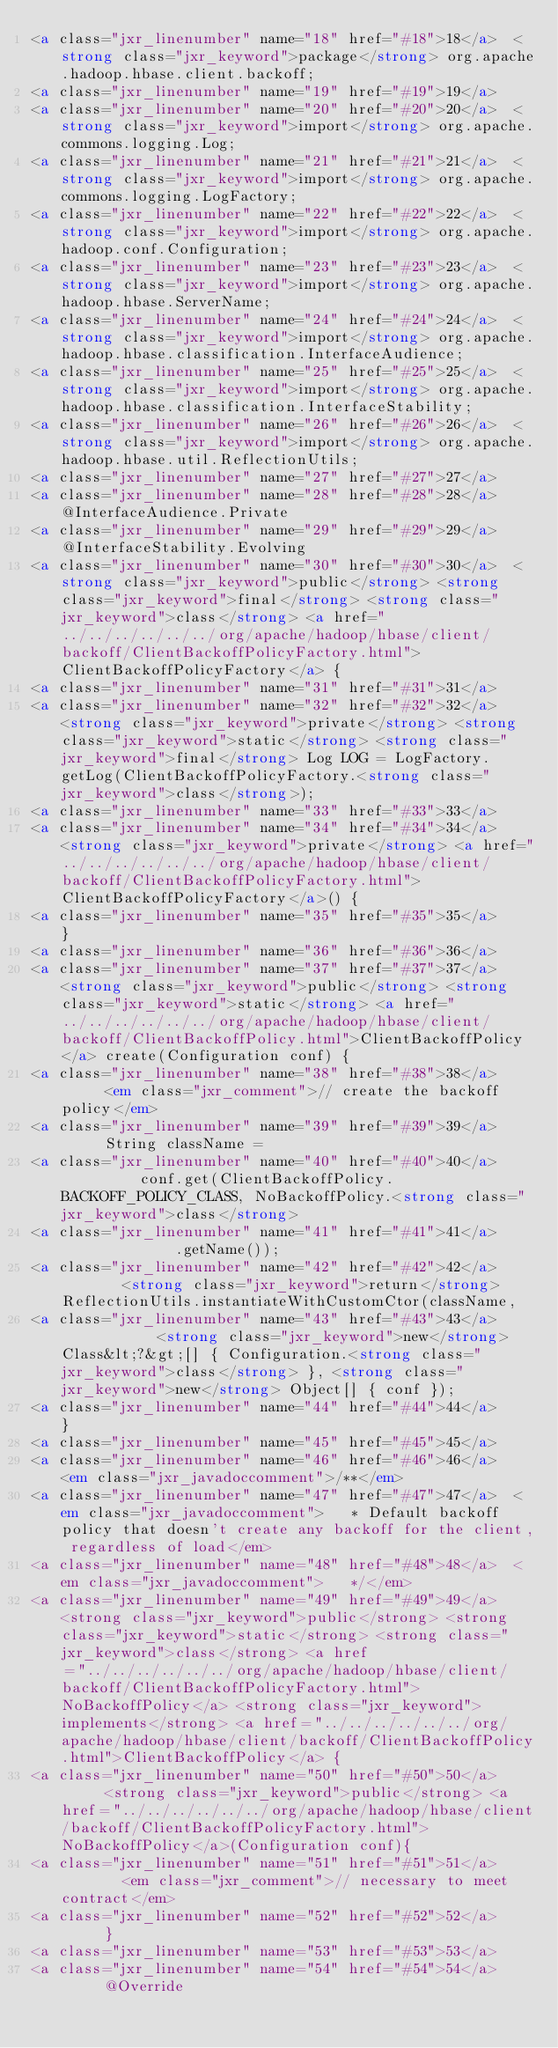Convert code to text. <code><loc_0><loc_0><loc_500><loc_500><_HTML_><a class="jxr_linenumber" name="18" href="#18">18</a>  <strong class="jxr_keyword">package</strong> org.apache.hadoop.hbase.client.backoff;
<a class="jxr_linenumber" name="19" href="#19">19</a>  
<a class="jxr_linenumber" name="20" href="#20">20</a>  <strong class="jxr_keyword">import</strong> org.apache.commons.logging.Log;
<a class="jxr_linenumber" name="21" href="#21">21</a>  <strong class="jxr_keyword">import</strong> org.apache.commons.logging.LogFactory;
<a class="jxr_linenumber" name="22" href="#22">22</a>  <strong class="jxr_keyword">import</strong> org.apache.hadoop.conf.Configuration;
<a class="jxr_linenumber" name="23" href="#23">23</a>  <strong class="jxr_keyword">import</strong> org.apache.hadoop.hbase.ServerName;
<a class="jxr_linenumber" name="24" href="#24">24</a>  <strong class="jxr_keyword">import</strong> org.apache.hadoop.hbase.classification.InterfaceAudience;
<a class="jxr_linenumber" name="25" href="#25">25</a>  <strong class="jxr_keyword">import</strong> org.apache.hadoop.hbase.classification.InterfaceStability;
<a class="jxr_linenumber" name="26" href="#26">26</a>  <strong class="jxr_keyword">import</strong> org.apache.hadoop.hbase.util.ReflectionUtils;
<a class="jxr_linenumber" name="27" href="#27">27</a>  
<a class="jxr_linenumber" name="28" href="#28">28</a>  @InterfaceAudience.Private
<a class="jxr_linenumber" name="29" href="#29">29</a>  @InterfaceStability.Evolving
<a class="jxr_linenumber" name="30" href="#30">30</a>  <strong class="jxr_keyword">public</strong> <strong class="jxr_keyword">final</strong> <strong class="jxr_keyword">class</strong> <a href="../../../../../../org/apache/hadoop/hbase/client/backoff/ClientBackoffPolicyFactory.html">ClientBackoffPolicyFactory</a> {
<a class="jxr_linenumber" name="31" href="#31">31</a>  
<a class="jxr_linenumber" name="32" href="#32">32</a>    <strong class="jxr_keyword">private</strong> <strong class="jxr_keyword">static</strong> <strong class="jxr_keyword">final</strong> Log LOG = LogFactory.getLog(ClientBackoffPolicyFactory.<strong class="jxr_keyword">class</strong>);
<a class="jxr_linenumber" name="33" href="#33">33</a>  
<a class="jxr_linenumber" name="34" href="#34">34</a>    <strong class="jxr_keyword">private</strong> <a href="../../../../../../org/apache/hadoop/hbase/client/backoff/ClientBackoffPolicyFactory.html">ClientBackoffPolicyFactory</a>() {
<a class="jxr_linenumber" name="35" href="#35">35</a>    }
<a class="jxr_linenumber" name="36" href="#36">36</a>  
<a class="jxr_linenumber" name="37" href="#37">37</a>    <strong class="jxr_keyword">public</strong> <strong class="jxr_keyword">static</strong> <a href="../../../../../../org/apache/hadoop/hbase/client/backoff/ClientBackoffPolicy.html">ClientBackoffPolicy</a> create(Configuration conf) {
<a class="jxr_linenumber" name="38" href="#38">38</a>      <em class="jxr_comment">// create the backoff policy</em>
<a class="jxr_linenumber" name="39" href="#39">39</a>      String className =
<a class="jxr_linenumber" name="40" href="#40">40</a>          conf.get(ClientBackoffPolicy.BACKOFF_POLICY_CLASS, NoBackoffPolicy.<strong class="jxr_keyword">class</strong>
<a class="jxr_linenumber" name="41" href="#41">41</a>              .getName());
<a class="jxr_linenumber" name="42" href="#42">42</a>        <strong class="jxr_keyword">return</strong> ReflectionUtils.instantiateWithCustomCtor(className,
<a class="jxr_linenumber" name="43" href="#43">43</a>            <strong class="jxr_keyword">new</strong> Class&lt;?&gt;[] { Configuration.<strong class="jxr_keyword">class</strong> }, <strong class="jxr_keyword">new</strong> Object[] { conf });
<a class="jxr_linenumber" name="44" href="#44">44</a>    }
<a class="jxr_linenumber" name="45" href="#45">45</a>  
<a class="jxr_linenumber" name="46" href="#46">46</a>    <em class="jxr_javadoccomment">/**</em>
<a class="jxr_linenumber" name="47" href="#47">47</a>  <em class="jxr_javadoccomment">   * Default backoff policy that doesn't create any backoff for the client, regardless of load</em>
<a class="jxr_linenumber" name="48" href="#48">48</a>  <em class="jxr_javadoccomment">   */</em>
<a class="jxr_linenumber" name="49" href="#49">49</a>    <strong class="jxr_keyword">public</strong> <strong class="jxr_keyword">static</strong> <strong class="jxr_keyword">class</strong> <a href="../../../../../../org/apache/hadoop/hbase/client/backoff/ClientBackoffPolicyFactory.html">NoBackoffPolicy</a> <strong class="jxr_keyword">implements</strong> <a href="../../../../../../org/apache/hadoop/hbase/client/backoff/ClientBackoffPolicy.html">ClientBackoffPolicy</a> {
<a class="jxr_linenumber" name="50" href="#50">50</a>      <strong class="jxr_keyword">public</strong> <a href="../../../../../../org/apache/hadoop/hbase/client/backoff/ClientBackoffPolicyFactory.html">NoBackoffPolicy</a>(Configuration conf){
<a class="jxr_linenumber" name="51" href="#51">51</a>        <em class="jxr_comment">// necessary to meet contract</em>
<a class="jxr_linenumber" name="52" href="#52">52</a>      }
<a class="jxr_linenumber" name="53" href="#53">53</a>  
<a class="jxr_linenumber" name="54" href="#54">54</a>      @Override</code> 